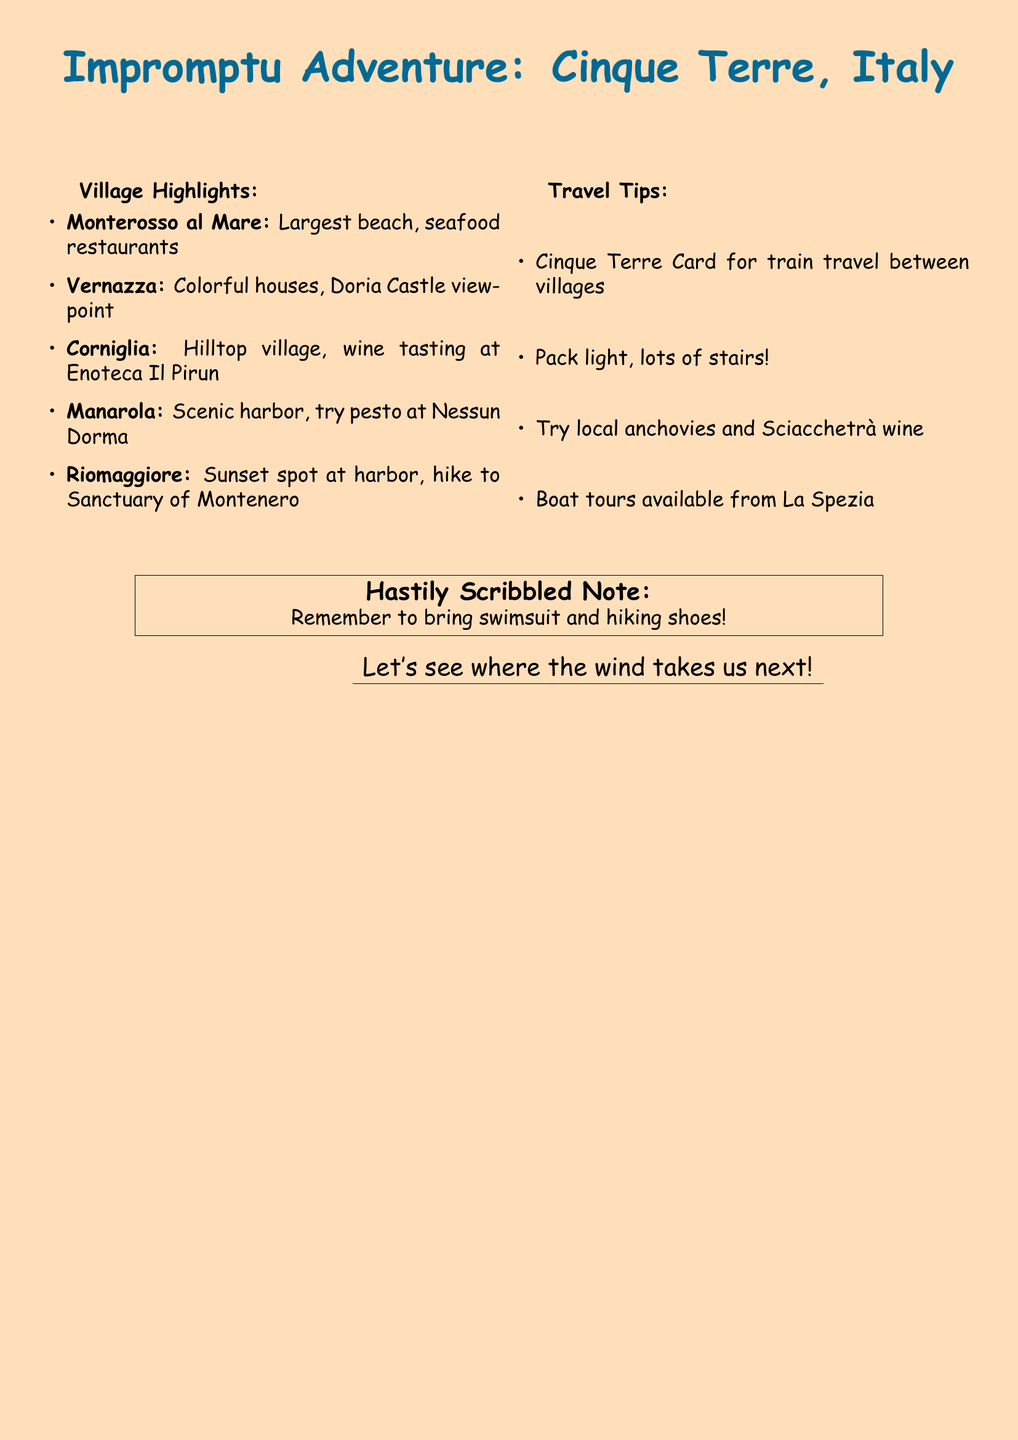What is the largest beach in Cinque Terre? The document mentions that Monterosso al Mare has the largest beach.
Answer: Monterosso al Mare What local food should you try in Manarola? The document suggests trying pesto at Nessun Dorma in Manarola.
Answer: Pesto Which village is known for a viewpoint at Doria Castle? The document indicates that Vernazza has a viewpoint at Doria Castle.
Answer: Vernazza What travel card is recommended for train travel? The document mentions the Cinque Terre Card for train travel between villages.
Answer: Cinque Terre Card What should you remember to bring according to the hastily scribbled note? The note emphasizes remembering to bring a swimsuit and hiking shoes.
Answer: Swimsuit and hiking shoes How many villages are highlighted in the document? The document lists five villages as highlights in Cinque Terre.
Answer: Five What local wine is recommended to try? The document advises trying Sciacchetrà wine, a local specialty.
Answer: Sciacchetrà What activity is available from La Spezia? The document mentions that boat tours are available from La Spezia.
Answer: Boat tours What type of document is this? Based on its content and format, this is a hastily scanned map with handwritten annotations.
Answer: Fax 